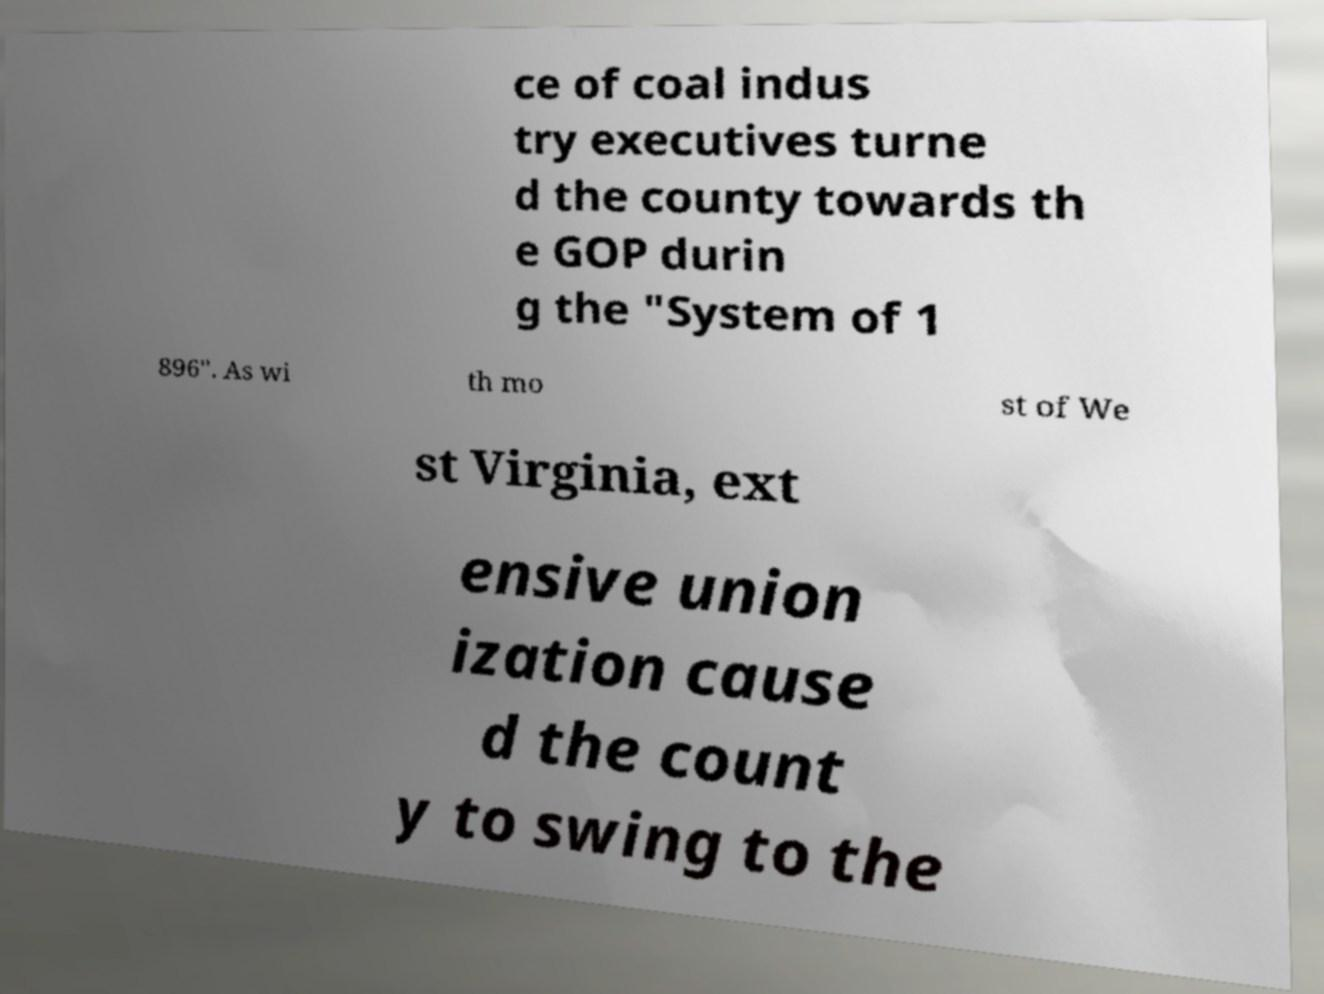Can you read and provide the text displayed in the image?This photo seems to have some interesting text. Can you extract and type it out for me? ce of coal indus try executives turne d the county towards th e GOP durin g the "System of 1 896". As wi th mo st of We st Virginia, ext ensive union ization cause d the count y to swing to the 